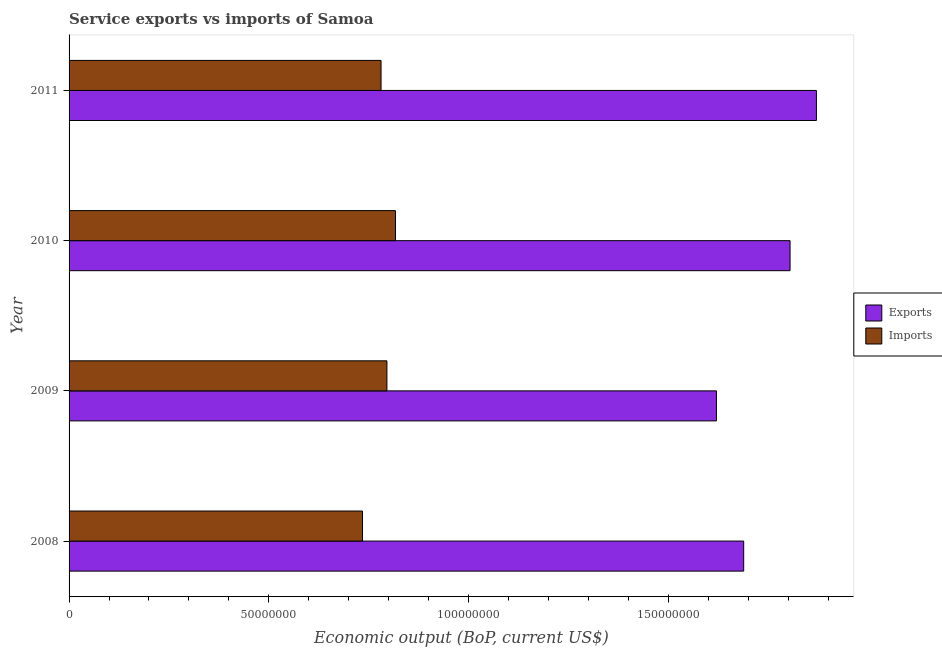How many groups of bars are there?
Your answer should be very brief. 4. Are the number of bars on each tick of the Y-axis equal?
Your answer should be very brief. Yes. How many bars are there on the 1st tick from the top?
Your answer should be compact. 2. How many bars are there on the 4th tick from the bottom?
Your answer should be compact. 2. In how many cases, is the number of bars for a given year not equal to the number of legend labels?
Your response must be concise. 0. What is the amount of service imports in 2009?
Ensure brevity in your answer.  7.96e+07. Across all years, what is the maximum amount of service exports?
Provide a short and direct response. 1.87e+08. Across all years, what is the minimum amount of service exports?
Keep it short and to the point. 1.62e+08. In which year was the amount of service imports maximum?
Your answer should be very brief. 2010. What is the total amount of service exports in the graph?
Provide a short and direct response. 6.99e+08. What is the difference between the amount of service imports in 2009 and that in 2010?
Ensure brevity in your answer.  -2.14e+06. What is the difference between the amount of service exports in 2011 and the amount of service imports in 2010?
Provide a succinct answer. 1.05e+08. What is the average amount of service imports per year?
Your answer should be very brief. 7.82e+07. In the year 2010, what is the difference between the amount of service exports and amount of service imports?
Give a very brief answer. 9.88e+07. What is the ratio of the amount of service exports in 2010 to that in 2011?
Ensure brevity in your answer.  0.96. Is the difference between the amount of service exports in 2008 and 2009 greater than the difference between the amount of service imports in 2008 and 2009?
Provide a short and direct response. Yes. What is the difference between the highest and the second highest amount of service exports?
Your answer should be very brief. 6.60e+06. What is the difference between the highest and the lowest amount of service exports?
Offer a terse response. 2.50e+07. Is the sum of the amount of service exports in 2009 and 2010 greater than the maximum amount of service imports across all years?
Your answer should be very brief. Yes. What does the 1st bar from the top in 2011 represents?
Offer a terse response. Imports. What does the 2nd bar from the bottom in 2008 represents?
Ensure brevity in your answer.  Imports. How many bars are there?
Ensure brevity in your answer.  8. Are all the bars in the graph horizontal?
Provide a short and direct response. Yes. How many years are there in the graph?
Provide a short and direct response. 4. What is the difference between two consecutive major ticks on the X-axis?
Your response must be concise. 5.00e+07. How many legend labels are there?
Offer a terse response. 2. How are the legend labels stacked?
Provide a succinct answer. Vertical. What is the title of the graph?
Offer a very short reply. Service exports vs imports of Samoa. What is the label or title of the X-axis?
Offer a very short reply. Economic output (BoP, current US$). What is the Economic output (BoP, current US$) in Exports in 2008?
Your answer should be very brief. 1.69e+08. What is the Economic output (BoP, current US$) in Imports in 2008?
Ensure brevity in your answer.  7.35e+07. What is the Economic output (BoP, current US$) of Exports in 2009?
Ensure brevity in your answer.  1.62e+08. What is the Economic output (BoP, current US$) of Imports in 2009?
Keep it short and to the point. 7.96e+07. What is the Economic output (BoP, current US$) of Exports in 2010?
Your answer should be very brief. 1.80e+08. What is the Economic output (BoP, current US$) in Imports in 2010?
Your answer should be very brief. 8.17e+07. What is the Economic output (BoP, current US$) of Exports in 2011?
Ensure brevity in your answer.  1.87e+08. What is the Economic output (BoP, current US$) in Imports in 2011?
Provide a short and direct response. 7.81e+07. Across all years, what is the maximum Economic output (BoP, current US$) of Exports?
Your response must be concise. 1.87e+08. Across all years, what is the maximum Economic output (BoP, current US$) in Imports?
Your answer should be very brief. 8.17e+07. Across all years, what is the minimum Economic output (BoP, current US$) of Exports?
Provide a short and direct response. 1.62e+08. Across all years, what is the minimum Economic output (BoP, current US$) in Imports?
Ensure brevity in your answer.  7.35e+07. What is the total Economic output (BoP, current US$) of Exports in the graph?
Your response must be concise. 6.99e+08. What is the total Economic output (BoP, current US$) of Imports in the graph?
Keep it short and to the point. 3.13e+08. What is the difference between the Economic output (BoP, current US$) in Exports in 2008 and that in 2009?
Your answer should be compact. 6.82e+06. What is the difference between the Economic output (BoP, current US$) of Imports in 2008 and that in 2009?
Make the answer very short. -6.12e+06. What is the difference between the Economic output (BoP, current US$) of Exports in 2008 and that in 2010?
Offer a very short reply. -1.16e+07. What is the difference between the Economic output (BoP, current US$) in Imports in 2008 and that in 2010?
Make the answer very short. -8.26e+06. What is the difference between the Economic output (BoP, current US$) in Exports in 2008 and that in 2011?
Your answer should be very brief. -1.82e+07. What is the difference between the Economic output (BoP, current US$) of Imports in 2008 and that in 2011?
Your answer should be compact. -4.65e+06. What is the difference between the Economic output (BoP, current US$) in Exports in 2009 and that in 2010?
Your answer should be very brief. -1.84e+07. What is the difference between the Economic output (BoP, current US$) of Imports in 2009 and that in 2010?
Your answer should be compact. -2.14e+06. What is the difference between the Economic output (BoP, current US$) of Exports in 2009 and that in 2011?
Offer a very short reply. -2.50e+07. What is the difference between the Economic output (BoP, current US$) in Imports in 2009 and that in 2011?
Provide a succinct answer. 1.47e+06. What is the difference between the Economic output (BoP, current US$) of Exports in 2010 and that in 2011?
Keep it short and to the point. -6.60e+06. What is the difference between the Economic output (BoP, current US$) in Imports in 2010 and that in 2011?
Your answer should be compact. 3.62e+06. What is the difference between the Economic output (BoP, current US$) of Exports in 2008 and the Economic output (BoP, current US$) of Imports in 2009?
Offer a very short reply. 8.93e+07. What is the difference between the Economic output (BoP, current US$) in Exports in 2008 and the Economic output (BoP, current US$) in Imports in 2010?
Keep it short and to the point. 8.72e+07. What is the difference between the Economic output (BoP, current US$) of Exports in 2008 and the Economic output (BoP, current US$) of Imports in 2011?
Provide a short and direct response. 9.08e+07. What is the difference between the Economic output (BoP, current US$) in Exports in 2009 and the Economic output (BoP, current US$) in Imports in 2010?
Give a very brief answer. 8.03e+07. What is the difference between the Economic output (BoP, current US$) of Exports in 2009 and the Economic output (BoP, current US$) of Imports in 2011?
Ensure brevity in your answer.  8.40e+07. What is the difference between the Economic output (BoP, current US$) of Exports in 2010 and the Economic output (BoP, current US$) of Imports in 2011?
Offer a very short reply. 1.02e+08. What is the average Economic output (BoP, current US$) in Exports per year?
Offer a very short reply. 1.75e+08. What is the average Economic output (BoP, current US$) in Imports per year?
Ensure brevity in your answer.  7.82e+07. In the year 2008, what is the difference between the Economic output (BoP, current US$) of Exports and Economic output (BoP, current US$) of Imports?
Keep it short and to the point. 9.54e+07. In the year 2009, what is the difference between the Economic output (BoP, current US$) of Exports and Economic output (BoP, current US$) of Imports?
Provide a succinct answer. 8.25e+07. In the year 2010, what is the difference between the Economic output (BoP, current US$) of Exports and Economic output (BoP, current US$) of Imports?
Offer a terse response. 9.88e+07. In the year 2011, what is the difference between the Economic output (BoP, current US$) of Exports and Economic output (BoP, current US$) of Imports?
Your response must be concise. 1.09e+08. What is the ratio of the Economic output (BoP, current US$) in Exports in 2008 to that in 2009?
Your answer should be compact. 1.04. What is the ratio of the Economic output (BoP, current US$) of Imports in 2008 to that in 2009?
Your response must be concise. 0.92. What is the ratio of the Economic output (BoP, current US$) of Exports in 2008 to that in 2010?
Ensure brevity in your answer.  0.94. What is the ratio of the Economic output (BoP, current US$) in Imports in 2008 to that in 2010?
Offer a terse response. 0.9. What is the ratio of the Economic output (BoP, current US$) in Exports in 2008 to that in 2011?
Keep it short and to the point. 0.9. What is the ratio of the Economic output (BoP, current US$) in Imports in 2008 to that in 2011?
Make the answer very short. 0.94. What is the ratio of the Economic output (BoP, current US$) in Exports in 2009 to that in 2010?
Offer a very short reply. 0.9. What is the ratio of the Economic output (BoP, current US$) in Imports in 2009 to that in 2010?
Keep it short and to the point. 0.97. What is the ratio of the Economic output (BoP, current US$) in Exports in 2009 to that in 2011?
Your response must be concise. 0.87. What is the ratio of the Economic output (BoP, current US$) in Imports in 2009 to that in 2011?
Offer a terse response. 1.02. What is the ratio of the Economic output (BoP, current US$) of Exports in 2010 to that in 2011?
Provide a succinct answer. 0.96. What is the ratio of the Economic output (BoP, current US$) of Imports in 2010 to that in 2011?
Keep it short and to the point. 1.05. What is the difference between the highest and the second highest Economic output (BoP, current US$) in Exports?
Ensure brevity in your answer.  6.60e+06. What is the difference between the highest and the second highest Economic output (BoP, current US$) of Imports?
Provide a short and direct response. 2.14e+06. What is the difference between the highest and the lowest Economic output (BoP, current US$) of Exports?
Your response must be concise. 2.50e+07. What is the difference between the highest and the lowest Economic output (BoP, current US$) in Imports?
Keep it short and to the point. 8.26e+06. 